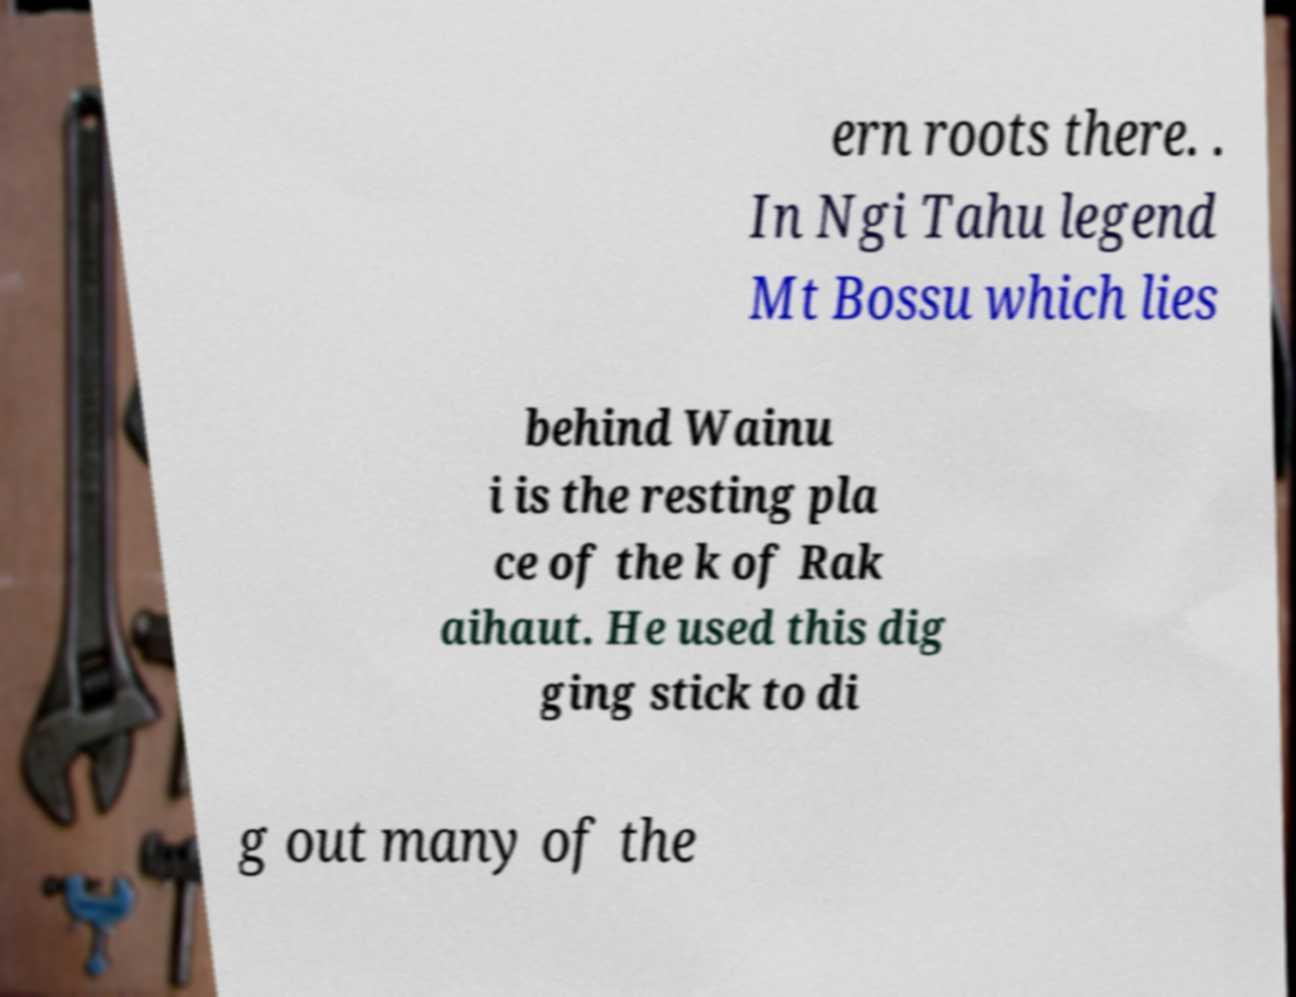Can you read and provide the text displayed in the image?This photo seems to have some interesting text. Can you extract and type it out for me? ern roots there. . In Ngi Tahu legend Mt Bossu which lies behind Wainu i is the resting pla ce of the k of Rak aihaut. He used this dig ging stick to di g out many of the 